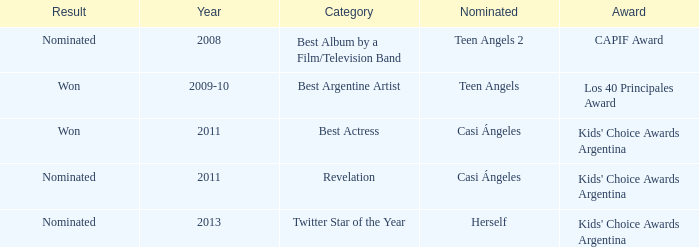Name the performance nominated for a Capif Award. Teen Angels 2. 